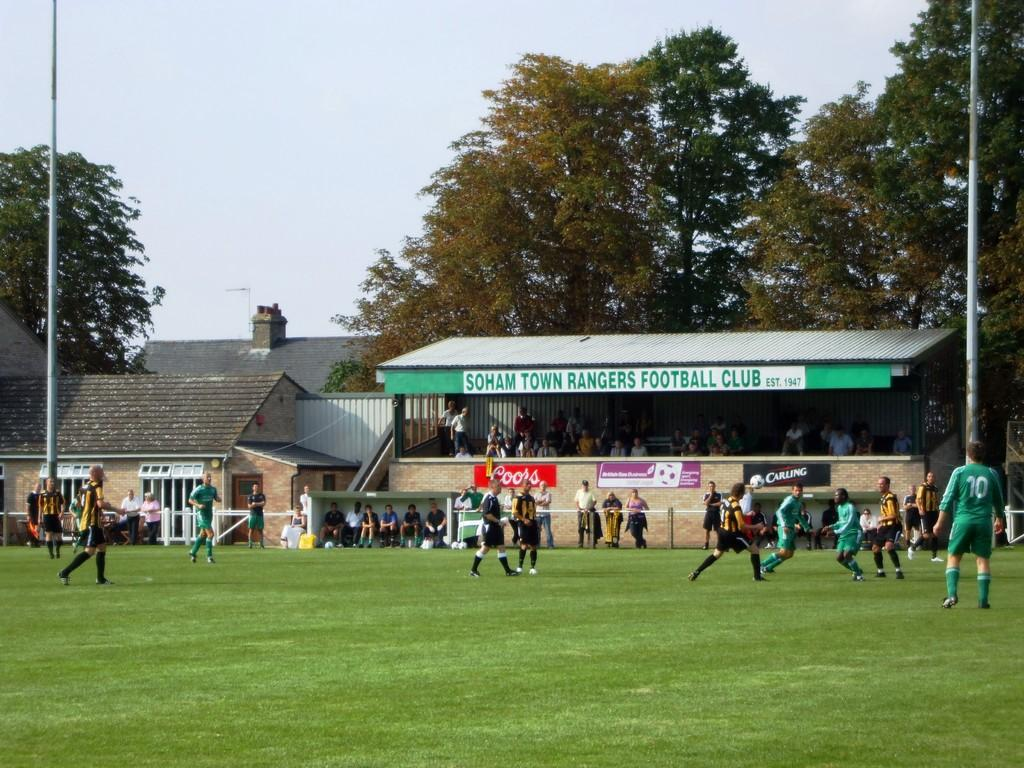<image>
Describe the image concisely. A field with athletes on a field that says Soham Town Rangers Football Club. 